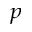<formula> <loc_0><loc_0><loc_500><loc_500>_ { p }</formula> 